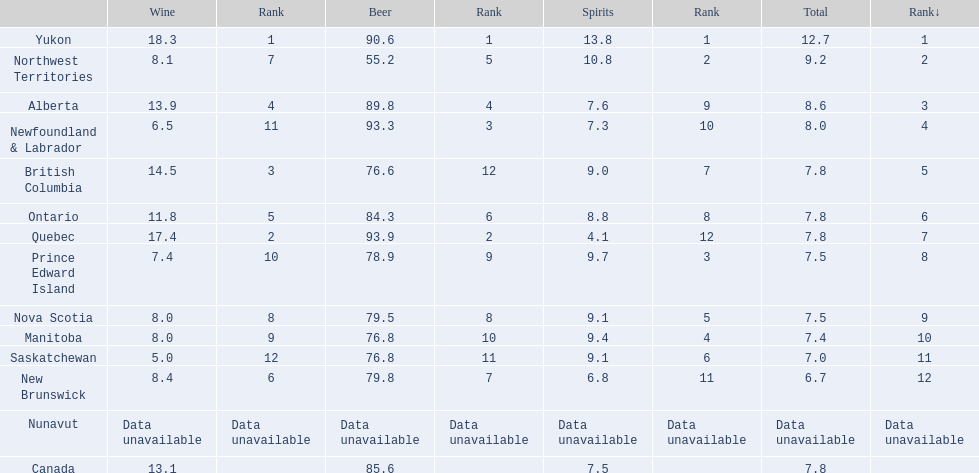What are the various regions in canada? Yukon, Northwest Territories, Alberta, Newfoundland & Labrador, British Columbia, Ontario, Quebec, Prince Edward Island, Nova Scotia, Manitoba, Saskatchewan, New Brunswick, Nunavut, Canada. What was the consumption of spirits? 13.8, 10.8, 7.6, 7.3, 9.0, 8.8, 4.1, 9.7, 9.1, 9.4, 9.1, 6.8, Data unavailable, 7.5. What was the consumption of spirits in quebec? 4.1. 